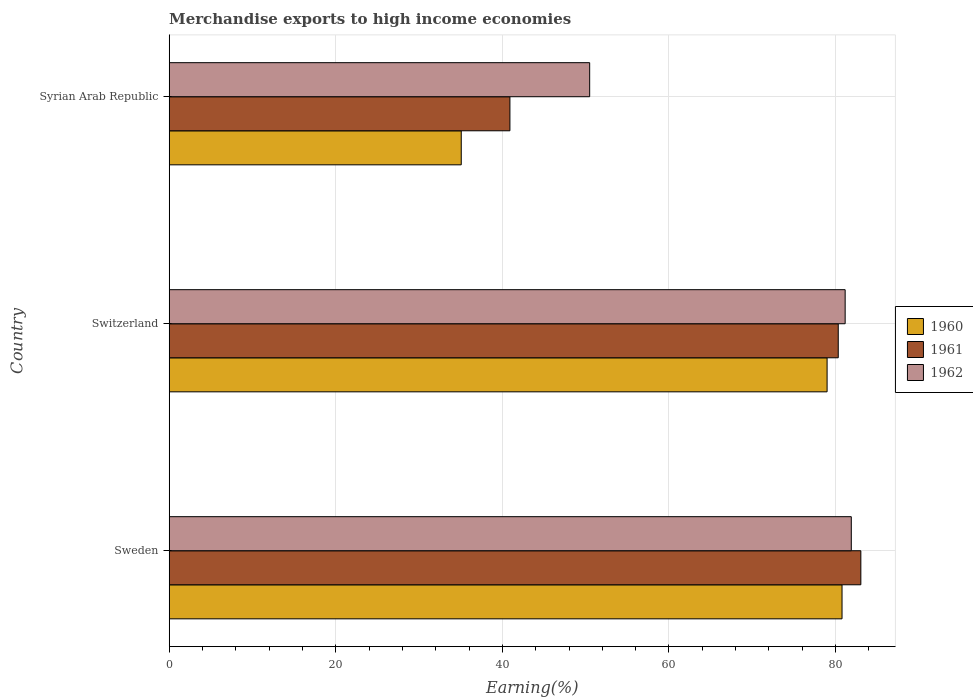How many groups of bars are there?
Make the answer very short. 3. What is the label of the 3rd group of bars from the top?
Make the answer very short. Sweden. What is the percentage of amount earned from merchandise exports in 1962 in Syrian Arab Republic?
Provide a succinct answer. 50.48. Across all countries, what is the maximum percentage of amount earned from merchandise exports in 1960?
Your response must be concise. 80.78. Across all countries, what is the minimum percentage of amount earned from merchandise exports in 1960?
Keep it short and to the point. 35.06. In which country was the percentage of amount earned from merchandise exports in 1960 maximum?
Offer a terse response. Sweden. In which country was the percentage of amount earned from merchandise exports in 1961 minimum?
Your response must be concise. Syrian Arab Republic. What is the total percentage of amount earned from merchandise exports in 1962 in the graph?
Offer a terse response. 213.52. What is the difference between the percentage of amount earned from merchandise exports in 1961 in Sweden and that in Syrian Arab Republic?
Offer a terse response. 42.13. What is the difference between the percentage of amount earned from merchandise exports in 1962 in Syrian Arab Republic and the percentage of amount earned from merchandise exports in 1961 in Switzerland?
Ensure brevity in your answer.  -29.84. What is the average percentage of amount earned from merchandise exports in 1961 per country?
Provide a short and direct response. 68.09. What is the difference between the percentage of amount earned from merchandise exports in 1961 and percentage of amount earned from merchandise exports in 1960 in Sweden?
Make the answer very short. 2.26. What is the ratio of the percentage of amount earned from merchandise exports in 1962 in Sweden to that in Syrian Arab Republic?
Your response must be concise. 1.62. Is the percentage of amount earned from merchandise exports in 1961 in Switzerland less than that in Syrian Arab Republic?
Your response must be concise. No. What is the difference between the highest and the second highest percentage of amount earned from merchandise exports in 1962?
Provide a short and direct response. 0.74. What is the difference between the highest and the lowest percentage of amount earned from merchandise exports in 1962?
Make the answer very short. 31.41. Is the sum of the percentage of amount earned from merchandise exports in 1962 in Sweden and Switzerland greater than the maximum percentage of amount earned from merchandise exports in 1961 across all countries?
Make the answer very short. Yes. What does the 2nd bar from the top in Sweden represents?
Offer a very short reply. 1961. What does the 1st bar from the bottom in Syrian Arab Republic represents?
Give a very brief answer. 1960. Is it the case that in every country, the sum of the percentage of amount earned from merchandise exports in 1961 and percentage of amount earned from merchandise exports in 1962 is greater than the percentage of amount earned from merchandise exports in 1960?
Give a very brief answer. Yes. How many bars are there?
Provide a short and direct response. 9. Are all the bars in the graph horizontal?
Provide a short and direct response. Yes. How many countries are there in the graph?
Your answer should be very brief. 3. What is the difference between two consecutive major ticks on the X-axis?
Make the answer very short. 20. How many legend labels are there?
Your answer should be compact. 3. How are the legend labels stacked?
Your answer should be compact. Vertical. What is the title of the graph?
Provide a short and direct response. Merchandise exports to high income economies. What is the label or title of the X-axis?
Offer a very short reply. Earning(%). What is the Earning(%) in 1960 in Sweden?
Provide a short and direct response. 80.78. What is the Earning(%) in 1961 in Sweden?
Your response must be concise. 83.03. What is the Earning(%) in 1962 in Sweden?
Make the answer very short. 81.89. What is the Earning(%) in 1960 in Switzerland?
Your response must be concise. 78.98. What is the Earning(%) in 1961 in Switzerland?
Your response must be concise. 80.32. What is the Earning(%) of 1962 in Switzerland?
Your answer should be very brief. 81.15. What is the Earning(%) in 1960 in Syrian Arab Republic?
Keep it short and to the point. 35.06. What is the Earning(%) in 1961 in Syrian Arab Republic?
Your answer should be compact. 40.9. What is the Earning(%) in 1962 in Syrian Arab Republic?
Give a very brief answer. 50.48. Across all countries, what is the maximum Earning(%) in 1960?
Keep it short and to the point. 80.78. Across all countries, what is the maximum Earning(%) in 1961?
Make the answer very short. 83.03. Across all countries, what is the maximum Earning(%) of 1962?
Provide a short and direct response. 81.89. Across all countries, what is the minimum Earning(%) of 1960?
Make the answer very short. 35.06. Across all countries, what is the minimum Earning(%) in 1961?
Your answer should be very brief. 40.9. Across all countries, what is the minimum Earning(%) of 1962?
Provide a short and direct response. 50.48. What is the total Earning(%) in 1960 in the graph?
Offer a very short reply. 194.82. What is the total Earning(%) of 1961 in the graph?
Make the answer very short. 204.26. What is the total Earning(%) of 1962 in the graph?
Offer a very short reply. 213.52. What is the difference between the Earning(%) in 1960 in Sweden and that in Switzerland?
Provide a short and direct response. 1.79. What is the difference between the Earning(%) of 1961 in Sweden and that in Switzerland?
Your answer should be very brief. 2.71. What is the difference between the Earning(%) in 1962 in Sweden and that in Switzerland?
Make the answer very short. 0.74. What is the difference between the Earning(%) in 1960 in Sweden and that in Syrian Arab Republic?
Give a very brief answer. 45.71. What is the difference between the Earning(%) of 1961 in Sweden and that in Syrian Arab Republic?
Make the answer very short. 42.13. What is the difference between the Earning(%) in 1962 in Sweden and that in Syrian Arab Republic?
Offer a very short reply. 31.41. What is the difference between the Earning(%) of 1960 in Switzerland and that in Syrian Arab Republic?
Make the answer very short. 43.92. What is the difference between the Earning(%) of 1961 in Switzerland and that in Syrian Arab Republic?
Provide a succinct answer. 39.42. What is the difference between the Earning(%) of 1962 in Switzerland and that in Syrian Arab Republic?
Offer a terse response. 30.67. What is the difference between the Earning(%) of 1960 in Sweden and the Earning(%) of 1961 in Switzerland?
Offer a terse response. 0.45. What is the difference between the Earning(%) in 1960 in Sweden and the Earning(%) in 1962 in Switzerland?
Your answer should be very brief. -0.38. What is the difference between the Earning(%) of 1961 in Sweden and the Earning(%) of 1962 in Switzerland?
Provide a short and direct response. 1.88. What is the difference between the Earning(%) of 1960 in Sweden and the Earning(%) of 1961 in Syrian Arab Republic?
Your answer should be very brief. 39.87. What is the difference between the Earning(%) of 1960 in Sweden and the Earning(%) of 1962 in Syrian Arab Republic?
Provide a succinct answer. 30.3. What is the difference between the Earning(%) in 1961 in Sweden and the Earning(%) in 1962 in Syrian Arab Republic?
Make the answer very short. 32.56. What is the difference between the Earning(%) in 1960 in Switzerland and the Earning(%) in 1961 in Syrian Arab Republic?
Offer a very short reply. 38.08. What is the difference between the Earning(%) in 1960 in Switzerland and the Earning(%) in 1962 in Syrian Arab Republic?
Offer a terse response. 28.5. What is the difference between the Earning(%) in 1961 in Switzerland and the Earning(%) in 1962 in Syrian Arab Republic?
Make the answer very short. 29.84. What is the average Earning(%) in 1960 per country?
Your response must be concise. 64.94. What is the average Earning(%) of 1961 per country?
Ensure brevity in your answer.  68.09. What is the average Earning(%) of 1962 per country?
Your answer should be very brief. 71.17. What is the difference between the Earning(%) of 1960 and Earning(%) of 1961 in Sweden?
Your answer should be compact. -2.26. What is the difference between the Earning(%) in 1960 and Earning(%) in 1962 in Sweden?
Give a very brief answer. -1.11. What is the difference between the Earning(%) in 1961 and Earning(%) in 1962 in Sweden?
Ensure brevity in your answer.  1.15. What is the difference between the Earning(%) of 1960 and Earning(%) of 1961 in Switzerland?
Ensure brevity in your answer.  -1.34. What is the difference between the Earning(%) in 1960 and Earning(%) in 1962 in Switzerland?
Ensure brevity in your answer.  -2.17. What is the difference between the Earning(%) in 1961 and Earning(%) in 1962 in Switzerland?
Provide a succinct answer. -0.83. What is the difference between the Earning(%) in 1960 and Earning(%) in 1961 in Syrian Arab Republic?
Make the answer very short. -5.84. What is the difference between the Earning(%) of 1960 and Earning(%) of 1962 in Syrian Arab Republic?
Give a very brief answer. -15.42. What is the difference between the Earning(%) in 1961 and Earning(%) in 1962 in Syrian Arab Republic?
Your response must be concise. -9.57. What is the ratio of the Earning(%) of 1960 in Sweden to that in Switzerland?
Keep it short and to the point. 1.02. What is the ratio of the Earning(%) of 1961 in Sweden to that in Switzerland?
Give a very brief answer. 1.03. What is the ratio of the Earning(%) of 1962 in Sweden to that in Switzerland?
Offer a terse response. 1.01. What is the ratio of the Earning(%) of 1960 in Sweden to that in Syrian Arab Republic?
Your answer should be compact. 2.3. What is the ratio of the Earning(%) of 1961 in Sweden to that in Syrian Arab Republic?
Your answer should be very brief. 2.03. What is the ratio of the Earning(%) in 1962 in Sweden to that in Syrian Arab Republic?
Keep it short and to the point. 1.62. What is the ratio of the Earning(%) in 1960 in Switzerland to that in Syrian Arab Republic?
Ensure brevity in your answer.  2.25. What is the ratio of the Earning(%) of 1961 in Switzerland to that in Syrian Arab Republic?
Provide a short and direct response. 1.96. What is the ratio of the Earning(%) of 1962 in Switzerland to that in Syrian Arab Republic?
Provide a succinct answer. 1.61. What is the difference between the highest and the second highest Earning(%) of 1960?
Make the answer very short. 1.79. What is the difference between the highest and the second highest Earning(%) in 1961?
Your response must be concise. 2.71. What is the difference between the highest and the second highest Earning(%) in 1962?
Your answer should be compact. 0.74. What is the difference between the highest and the lowest Earning(%) in 1960?
Ensure brevity in your answer.  45.71. What is the difference between the highest and the lowest Earning(%) of 1961?
Your response must be concise. 42.13. What is the difference between the highest and the lowest Earning(%) in 1962?
Ensure brevity in your answer.  31.41. 